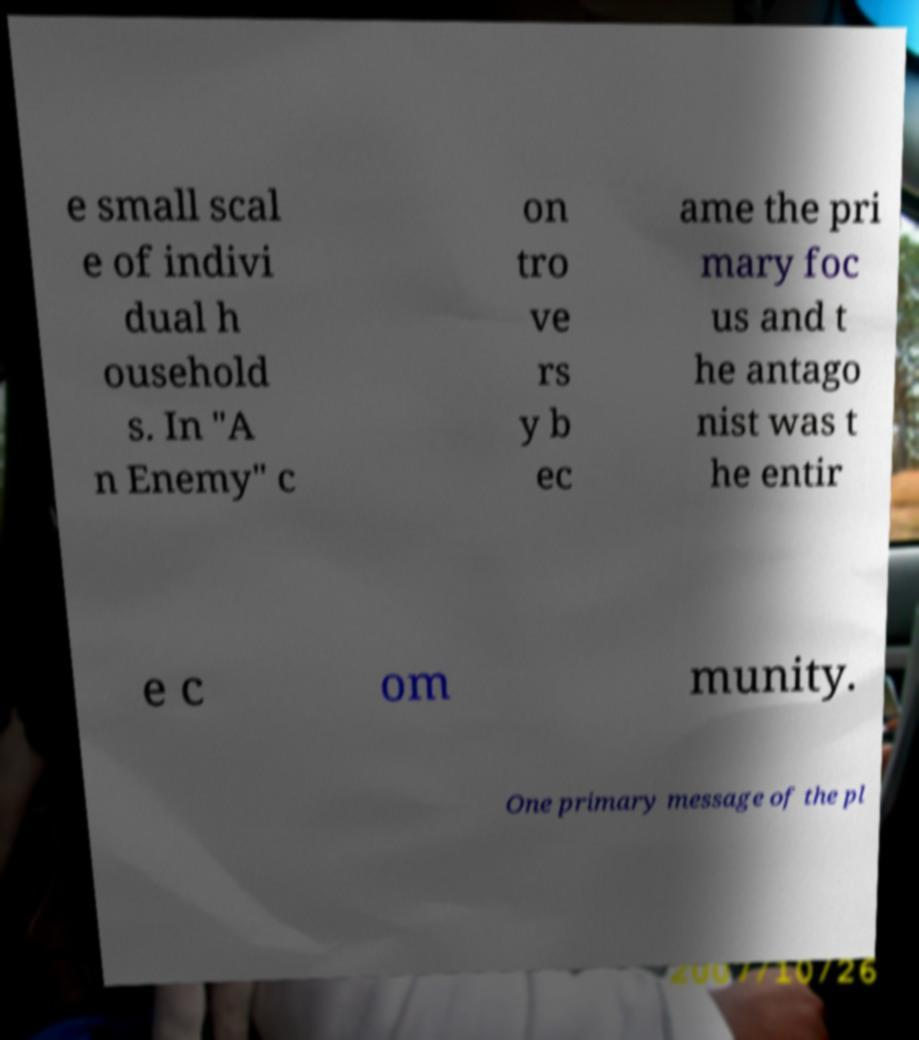For documentation purposes, I need the text within this image transcribed. Could you provide that? e small scal e of indivi dual h ousehold s. In "A n Enemy" c on tro ve rs y b ec ame the pri mary foc us and t he antago nist was t he entir e c om munity. One primary message of the pl 